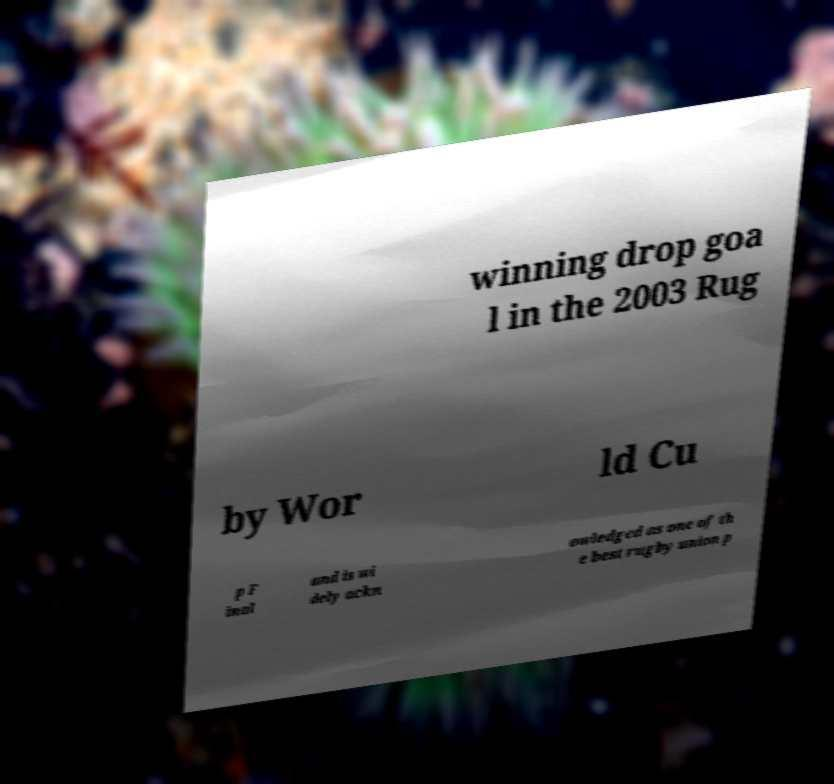For documentation purposes, I need the text within this image transcribed. Could you provide that? winning drop goa l in the 2003 Rug by Wor ld Cu p F inal and is wi dely ackn owledged as one of th e best rugby union p 